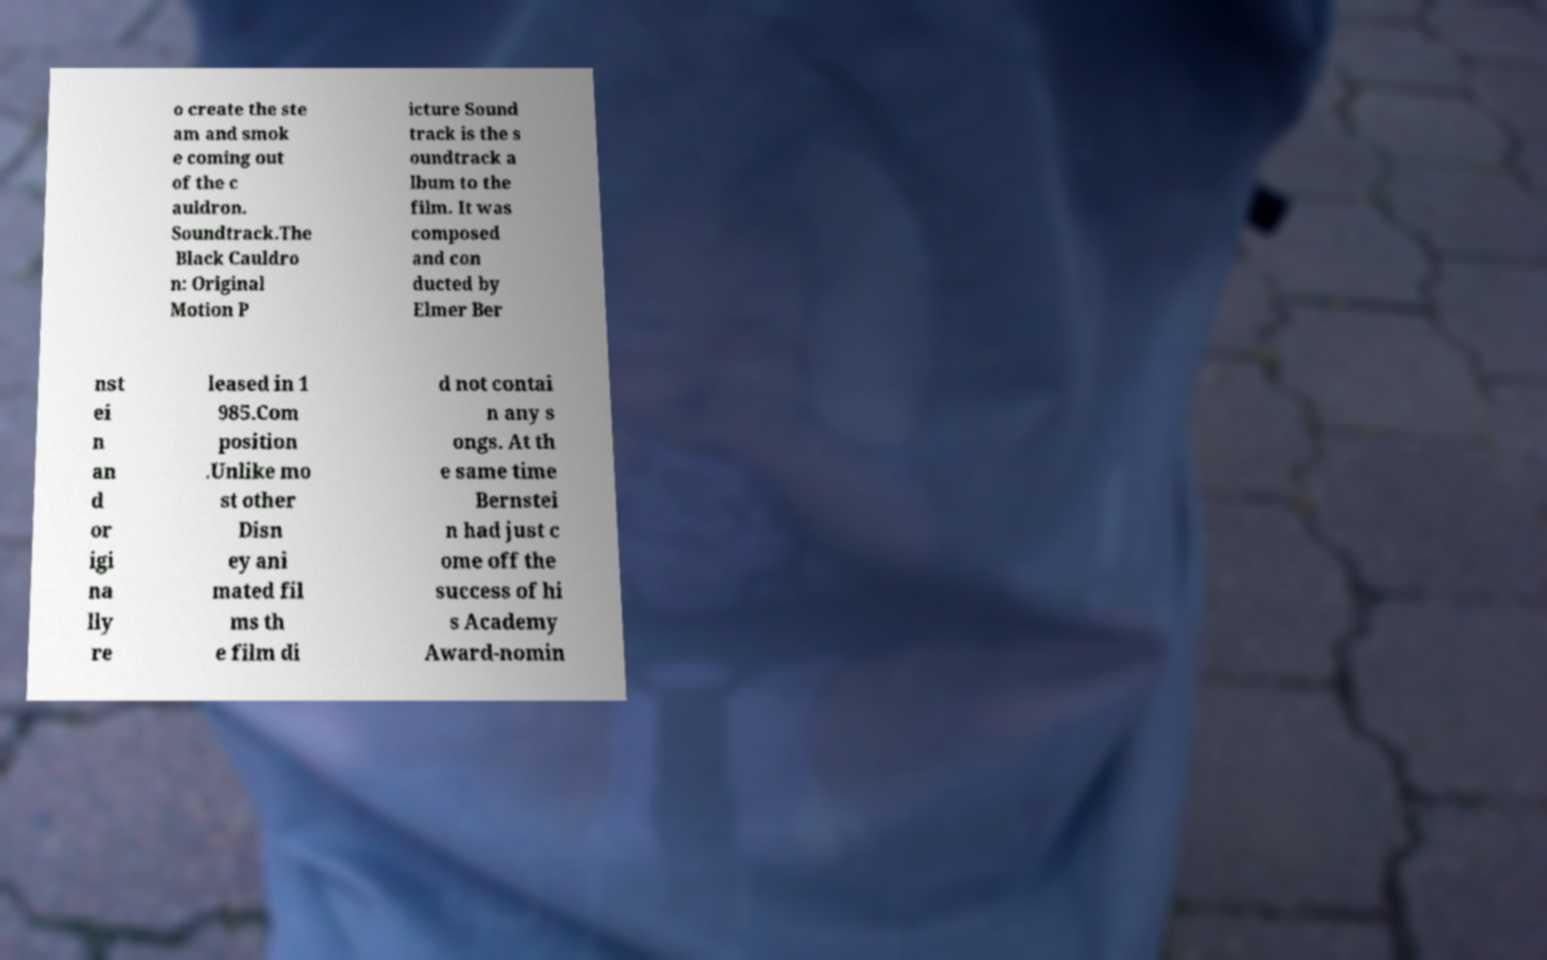Could you assist in decoding the text presented in this image and type it out clearly? o create the ste am and smok e coming out of the c auldron. Soundtrack.The Black Cauldro n: Original Motion P icture Sound track is the s oundtrack a lbum to the film. It was composed and con ducted by Elmer Ber nst ei n an d or igi na lly re leased in 1 985.Com position .Unlike mo st other Disn ey ani mated fil ms th e film di d not contai n any s ongs. At th e same time Bernstei n had just c ome off the success of hi s Academy Award-nomin 